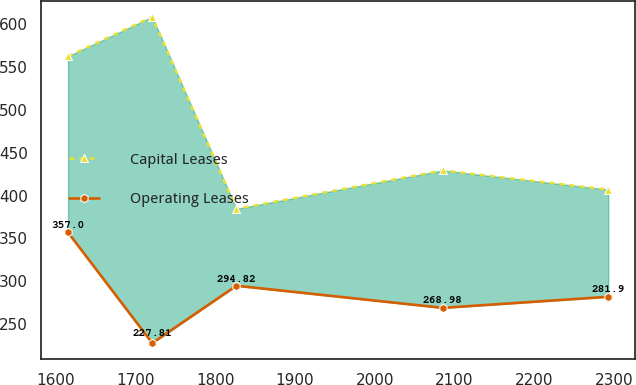Convert chart to OTSL. <chart><loc_0><loc_0><loc_500><loc_500><line_chart><ecel><fcel>Capital Leases<fcel>Operating Leases<nl><fcel>1615.47<fcel>562.67<fcel>357<nl><fcel>1721.08<fcel>608.62<fcel>227.81<nl><fcel>1826.54<fcel>384.57<fcel>294.82<nl><fcel>2085.34<fcel>429.38<fcel>268.98<nl><fcel>2292.75<fcel>406.98<fcel>281.9<nl></chart> 